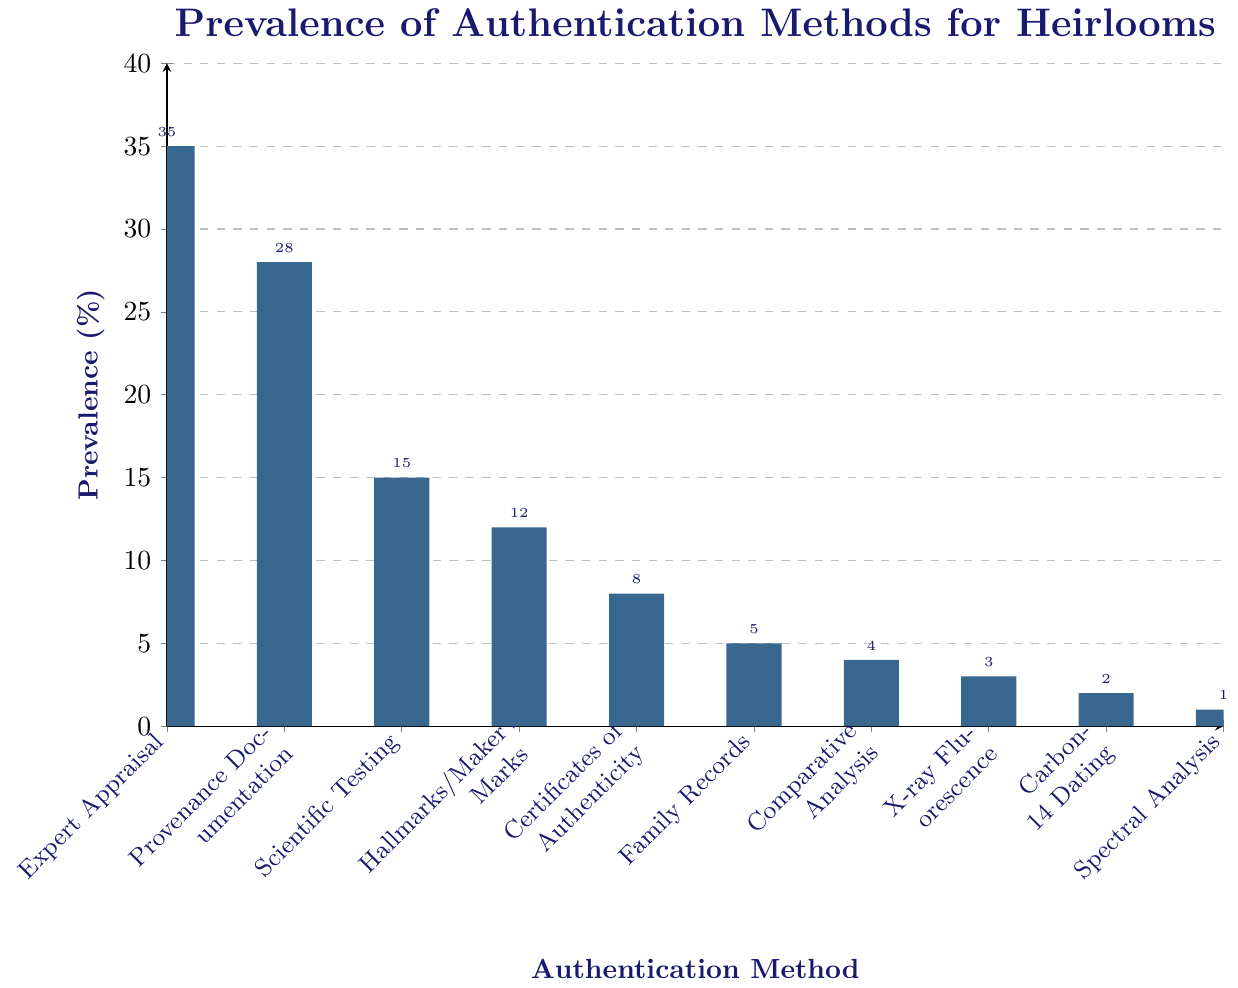What is the most prevalent method of authenticating heirlooms? To determine the most prevalent method, we look for the tallest bar in the chart. The tallest bar represents "Expert Appraisal" with a prevalence of 35%.
Answer: Expert Appraisal Which authentication method is associated with the least prevalence? The shortest bar on the chart signifies the least prevalent method. This bar represents "Spectral Analysis" with a prevalence of 1%.
Answer: Spectral Analysis How much more prevalent is "Provenance Documentation" compared to "Certificates of Authenticity"? To find the difference in prevalence, subtract the prevalence of "Certificates of Authenticity" from "Provenance Documentation." (28% - 8%) = 20%.
Answer: 20% What is the combined prevalence of "Scientific Testing", "Hallmarks/Maker's Marks", and "X-ray Fluorescence"? Calculate the sum of the prevalence percentages for the three methods. (15% + 12% + 3%) = 30%.
Answer: 30% Is "Family Records" more or less prevalent than "Comparative Analysis"? Compare the heights of the bars for "Family Records" and "Comparative Analysis." The prevalence of "Family Records" is 5%, which is more than "Comparative Analysis" at 4%.
Answer: More What is the combined prevalence of the three least common authentication methods? The three least common methods are "Spectral Analysis" (1%), "Carbon-14 Dating" (2%), and "X-ray Fluorescence" (3%). Sum these values: (1% + 2% + 3%) = 6%.
Answer: 6% How many authentication methods have a prevalence of less than 10%? Count the bars that have a height indicating a prevalence of less than 10%. These methods are "Certificates of Authenticity" (8%), "Family Records" (5%), "Comparative Analysis" (4%), "X-ray Fluorescence" (3%), "Carbon-14 Dating" (2%), and "Spectral Analysis" (1%). There are 6 such methods.
Answer: 6 Which is more prevalent: "Scientific Testing" or "Hallmarks/Maker's Marks"? By comparing the heights of the bars, "Scientific Testing" has a prevalence of 15%, while "Hallmarks/Maker's Marks" has a prevalence of 12%. Therefore, "Scientific Testing" is more prevalent.
Answer: Scientific Testing 